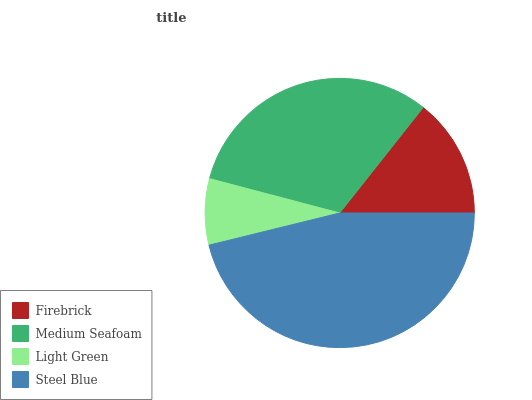Is Light Green the minimum?
Answer yes or no. Yes. Is Steel Blue the maximum?
Answer yes or no. Yes. Is Medium Seafoam the minimum?
Answer yes or no. No. Is Medium Seafoam the maximum?
Answer yes or no. No. Is Medium Seafoam greater than Firebrick?
Answer yes or no. Yes. Is Firebrick less than Medium Seafoam?
Answer yes or no. Yes. Is Firebrick greater than Medium Seafoam?
Answer yes or no. No. Is Medium Seafoam less than Firebrick?
Answer yes or no. No. Is Medium Seafoam the high median?
Answer yes or no. Yes. Is Firebrick the low median?
Answer yes or no. Yes. Is Firebrick the high median?
Answer yes or no. No. Is Steel Blue the low median?
Answer yes or no. No. 